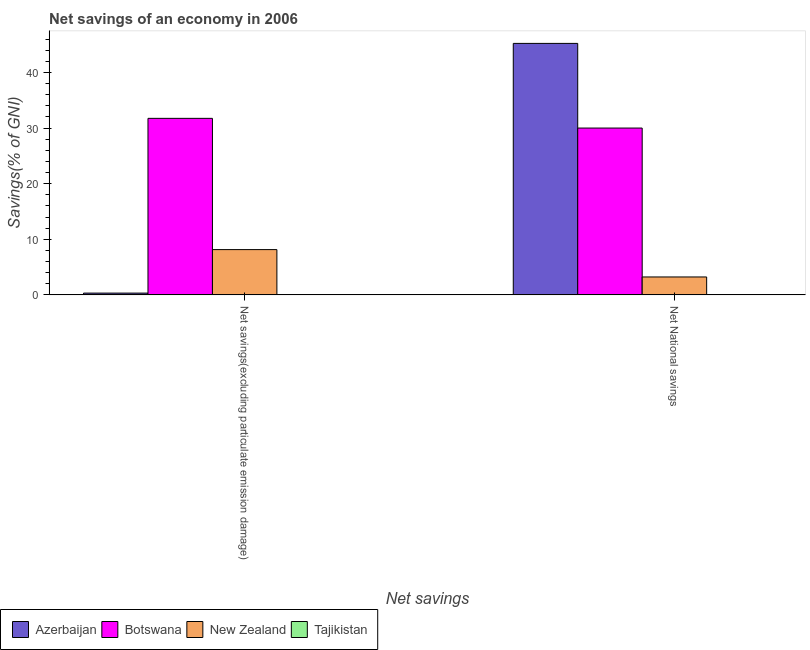How many different coloured bars are there?
Make the answer very short. 3. How many groups of bars are there?
Provide a short and direct response. 2. Are the number of bars per tick equal to the number of legend labels?
Your answer should be very brief. No. Are the number of bars on each tick of the X-axis equal?
Make the answer very short. Yes. How many bars are there on the 2nd tick from the left?
Keep it short and to the point. 3. How many bars are there on the 2nd tick from the right?
Offer a terse response. 3. What is the label of the 1st group of bars from the left?
Make the answer very short. Net savings(excluding particulate emission damage). What is the net national savings in Botswana?
Offer a very short reply. 30. Across all countries, what is the maximum net national savings?
Offer a very short reply. 45.22. In which country was the net savings(excluding particulate emission damage) maximum?
Your answer should be very brief. Botswana. What is the total net savings(excluding particulate emission damage) in the graph?
Keep it short and to the point. 40.21. What is the difference between the net savings(excluding particulate emission damage) in Azerbaijan and that in Botswana?
Your answer should be compact. -31.42. What is the difference between the net national savings in New Zealand and the net savings(excluding particulate emission damage) in Botswana?
Keep it short and to the point. -28.52. What is the average net savings(excluding particulate emission damage) per country?
Provide a short and direct response. 10.05. What is the difference between the net national savings and net savings(excluding particulate emission damage) in New Zealand?
Your answer should be compact. -4.92. What is the ratio of the net national savings in New Zealand to that in Botswana?
Your response must be concise. 0.11. Are the values on the major ticks of Y-axis written in scientific E-notation?
Your answer should be compact. No. Does the graph contain any zero values?
Keep it short and to the point. Yes. How many legend labels are there?
Offer a terse response. 4. How are the legend labels stacked?
Offer a terse response. Horizontal. What is the title of the graph?
Provide a short and direct response. Net savings of an economy in 2006. Does "Macao" appear as one of the legend labels in the graph?
Give a very brief answer. No. What is the label or title of the X-axis?
Offer a very short reply. Net savings. What is the label or title of the Y-axis?
Make the answer very short. Savings(% of GNI). What is the Savings(% of GNI) of Azerbaijan in Net savings(excluding particulate emission damage)?
Provide a short and direct response. 0.32. What is the Savings(% of GNI) of Botswana in Net savings(excluding particulate emission damage)?
Provide a short and direct response. 31.74. What is the Savings(% of GNI) in New Zealand in Net savings(excluding particulate emission damage)?
Provide a succinct answer. 8.14. What is the Savings(% of GNI) in Azerbaijan in Net National savings?
Provide a succinct answer. 45.22. What is the Savings(% of GNI) of Botswana in Net National savings?
Offer a very short reply. 30. What is the Savings(% of GNI) in New Zealand in Net National savings?
Your answer should be compact. 3.22. What is the Savings(% of GNI) of Tajikistan in Net National savings?
Give a very brief answer. 0. Across all Net savings, what is the maximum Savings(% of GNI) of Azerbaijan?
Give a very brief answer. 45.22. Across all Net savings, what is the maximum Savings(% of GNI) in Botswana?
Your answer should be compact. 31.74. Across all Net savings, what is the maximum Savings(% of GNI) of New Zealand?
Give a very brief answer. 8.14. Across all Net savings, what is the minimum Savings(% of GNI) in Azerbaijan?
Ensure brevity in your answer.  0.32. Across all Net savings, what is the minimum Savings(% of GNI) in Botswana?
Your answer should be compact. 30. Across all Net savings, what is the minimum Savings(% of GNI) in New Zealand?
Your response must be concise. 3.22. What is the total Savings(% of GNI) of Azerbaijan in the graph?
Offer a very short reply. 45.54. What is the total Savings(% of GNI) in Botswana in the graph?
Provide a succinct answer. 61.74. What is the total Savings(% of GNI) in New Zealand in the graph?
Your answer should be compact. 11.37. What is the total Savings(% of GNI) of Tajikistan in the graph?
Make the answer very short. 0. What is the difference between the Savings(% of GNI) of Azerbaijan in Net savings(excluding particulate emission damage) and that in Net National savings?
Your answer should be very brief. -44.9. What is the difference between the Savings(% of GNI) of Botswana in Net savings(excluding particulate emission damage) and that in Net National savings?
Make the answer very short. 1.74. What is the difference between the Savings(% of GNI) in New Zealand in Net savings(excluding particulate emission damage) and that in Net National savings?
Give a very brief answer. 4.92. What is the difference between the Savings(% of GNI) of Azerbaijan in Net savings(excluding particulate emission damage) and the Savings(% of GNI) of Botswana in Net National savings?
Provide a short and direct response. -29.68. What is the difference between the Savings(% of GNI) in Azerbaijan in Net savings(excluding particulate emission damage) and the Savings(% of GNI) in New Zealand in Net National savings?
Your answer should be compact. -2.9. What is the difference between the Savings(% of GNI) in Botswana in Net savings(excluding particulate emission damage) and the Savings(% of GNI) in New Zealand in Net National savings?
Provide a short and direct response. 28.52. What is the average Savings(% of GNI) in Azerbaijan per Net savings?
Provide a succinct answer. 22.77. What is the average Savings(% of GNI) in Botswana per Net savings?
Your response must be concise. 30.87. What is the average Savings(% of GNI) of New Zealand per Net savings?
Your answer should be very brief. 5.68. What is the average Savings(% of GNI) in Tajikistan per Net savings?
Give a very brief answer. 0. What is the difference between the Savings(% of GNI) in Azerbaijan and Savings(% of GNI) in Botswana in Net savings(excluding particulate emission damage)?
Your response must be concise. -31.42. What is the difference between the Savings(% of GNI) of Azerbaijan and Savings(% of GNI) of New Zealand in Net savings(excluding particulate emission damage)?
Offer a very short reply. -7.82. What is the difference between the Savings(% of GNI) of Botswana and Savings(% of GNI) of New Zealand in Net savings(excluding particulate emission damage)?
Give a very brief answer. 23.6. What is the difference between the Savings(% of GNI) in Azerbaijan and Savings(% of GNI) in Botswana in Net National savings?
Your answer should be very brief. 15.22. What is the difference between the Savings(% of GNI) in Azerbaijan and Savings(% of GNI) in New Zealand in Net National savings?
Provide a succinct answer. 42. What is the difference between the Savings(% of GNI) in Botswana and Savings(% of GNI) in New Zealand in Net National savings?
Provide a succinct answer. 26.77. What is the ratio of the Savings(% of GNI) in Azerbaijan in Net savings(excluding particulate emission damage) to that in Net National savings?
Provide a short and direct response. 0.01. What is the ratio of the Savings(% of GNI) in Botswana in Net savings(excluding particulate emission damage) to that in Net National savings?
Offer a very short reply. 1.06. What is the ratio of the Savings(% of GNI) in New Zealand in Net savings(excluding particulate emission damage) to that in Net National savings?
Offer a very short reply. 2.53. What is the difference between the highest and the second highest Savings(% of GNI) of Azerbaijan?
Your response must be concise. 44.9. What is the difference between the highest and the second highest Savings(% of GNI) of Botswana?
Ensure brevity in your answer.  1.74. What is the difference between the highest and the second highest Savings(% of GNI) of New Zealand?
Give a very brief answer. 4.92. What is the difference between the highest and the lowest Savings(% of GNI) in Azerbaijan?
Your answer should be very brief. 44.9. What is the difference between the highest and the lowest Savings(% of GNI) in Botswana?
Make the answer very short. 1.74. What is the difference between the highest and the lowest Savings(% of GNI) in New Zealand?
Offer a terse response. 4.92. 